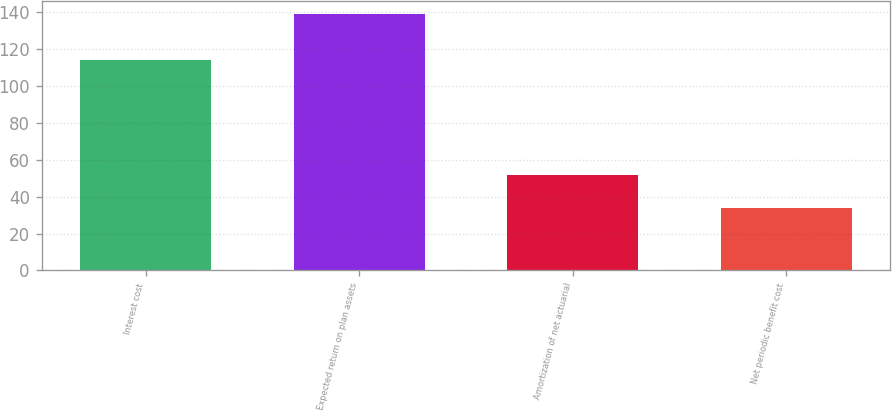Convert chart. <chart><loc_0><loc_0><loc_500><loc_500><bar_chart><fcel>Interest cost<fcel>Expected return on plan assets<fcel>Amortization of net actuarial<fcel>Net periodic benefit cost<nl><fcel>114<fcel>139<fcel>52<fcel>34<nl></chart> 